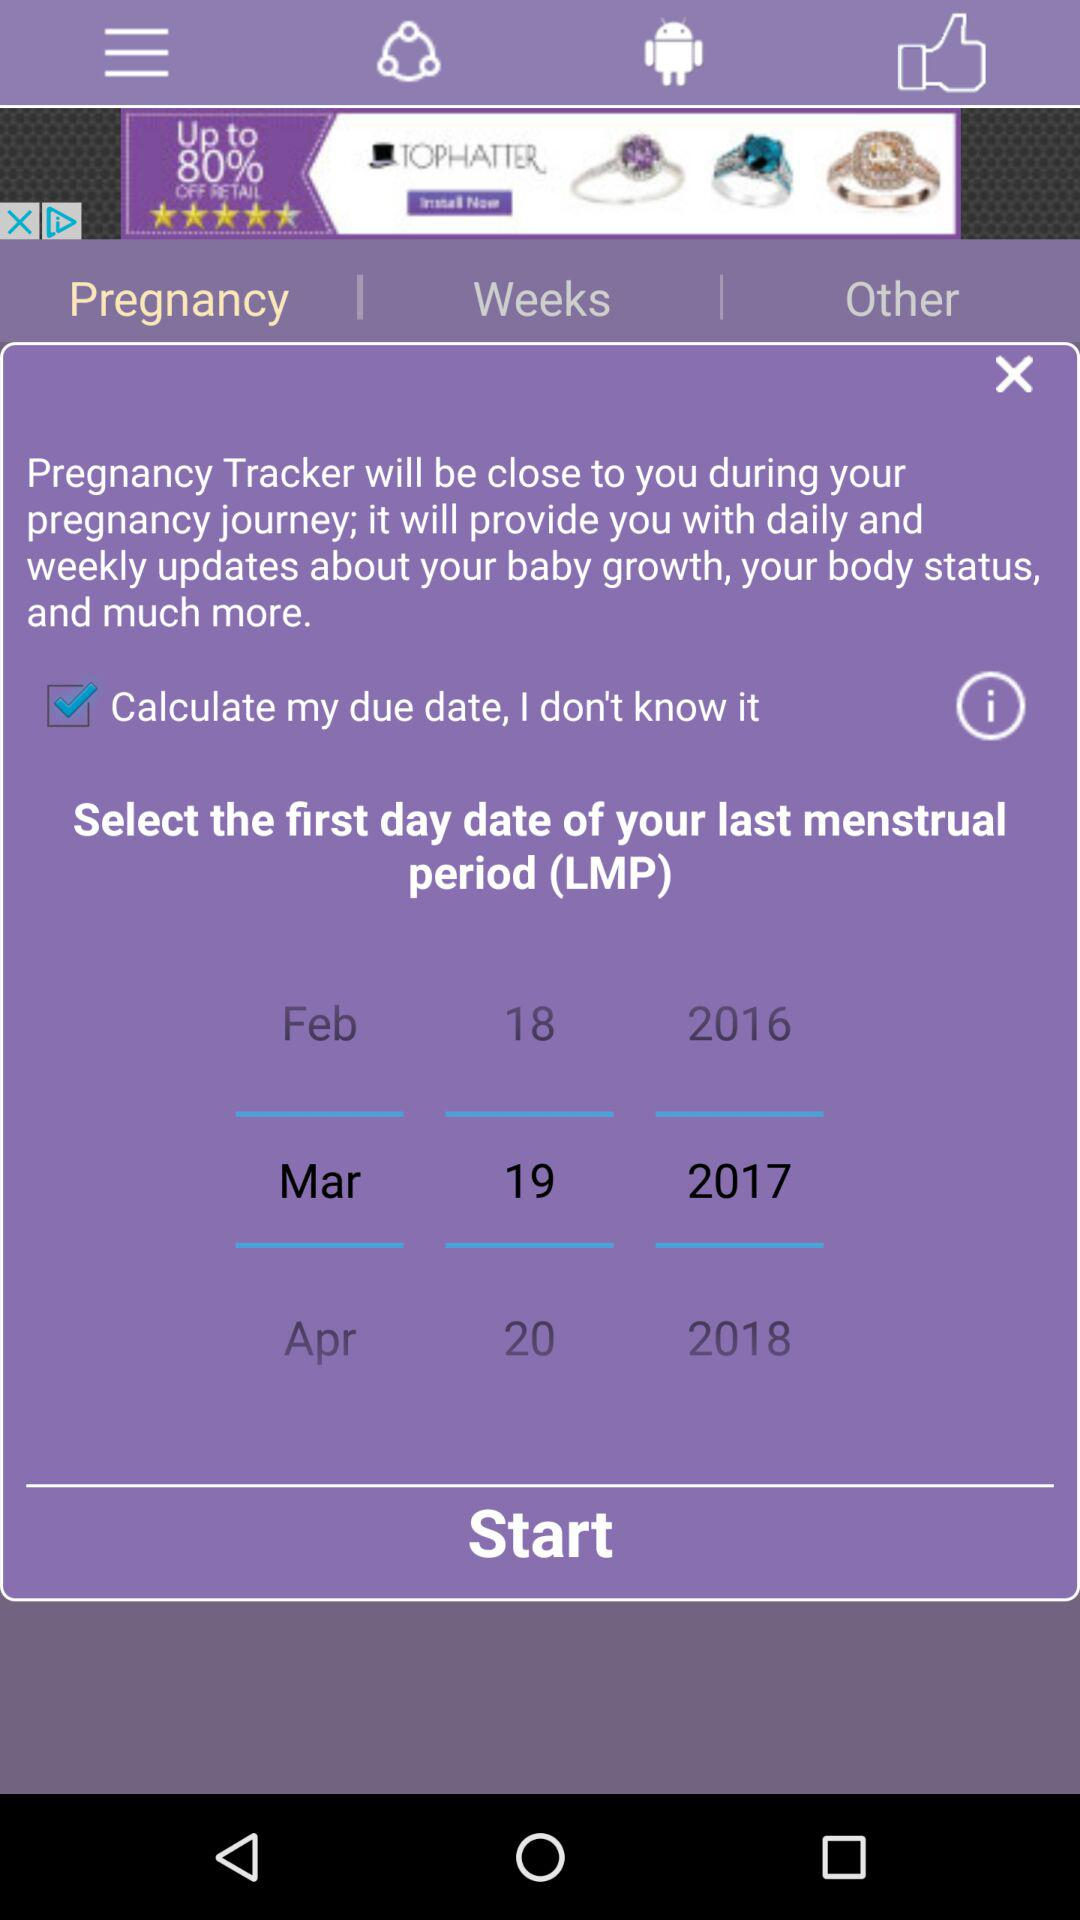What is the selected date? The selected date is March 19, 2017. 